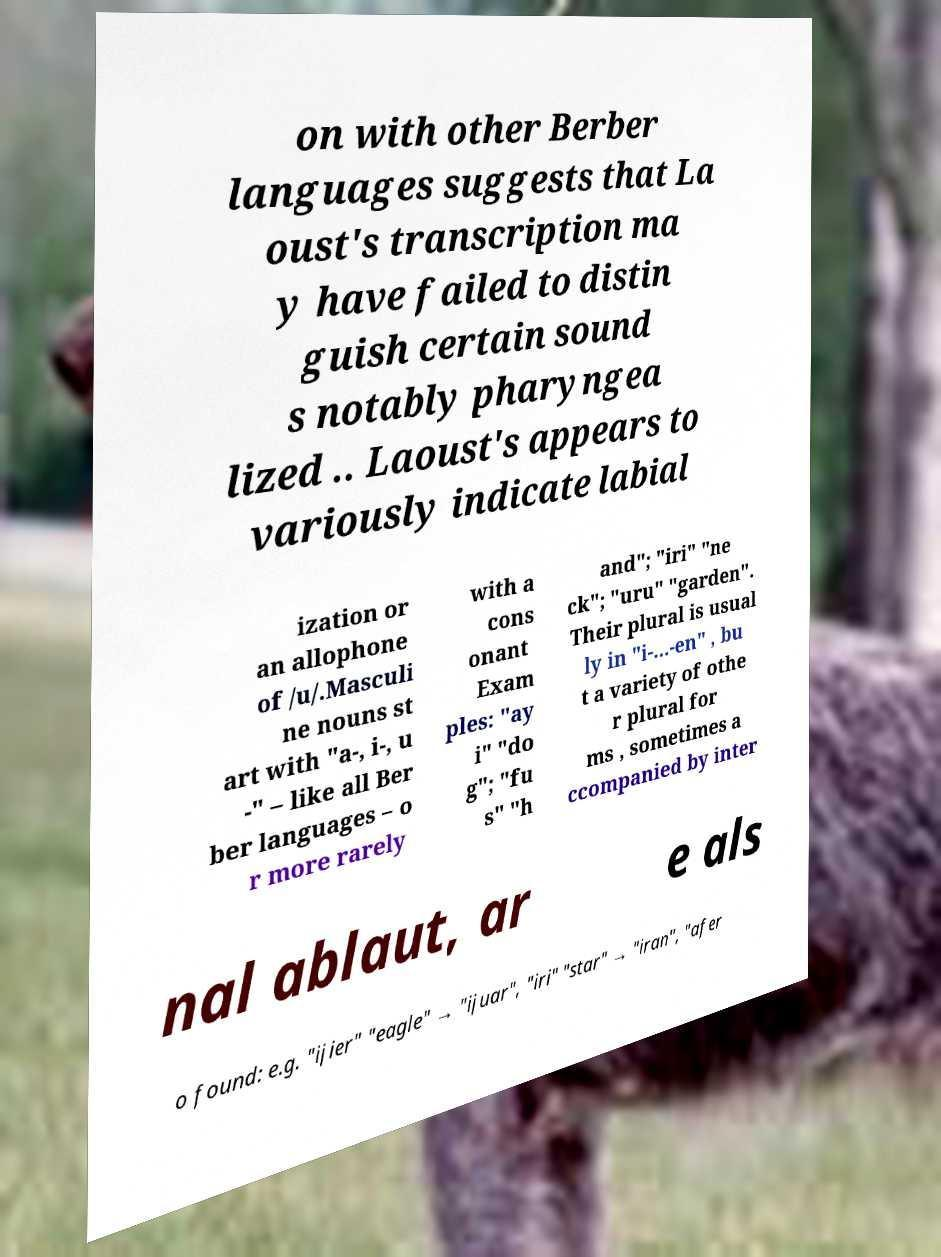Could you assist in decoding the text presented in this image and type it out clearly? on with other Berber languages suggests that La oust's transcription ma y have failed to distin guish certain sound s notably pharyngea lized .. Laoust's appears to variously indicate labial ization or an allophone of /u/.Masculi ne nouns st art with "a-, i-, u -" – like all Ber ber languages – o r more rarely with a cons onant Exam ples: "ay i" "do g"; "fu s" "h and"; "iri" "ne ck"; "uru" "garden". Their plural is usual ly in "i-...-en" , bu t a variety of othe r plural for ms , sometimes a ccompanied by inter nal ablaut, ar e als o found: e.g. "ijier" "eagle" → "ijuar", "iri" "star" → "iran", "afer 